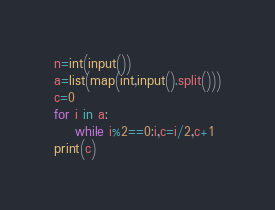Convert code to text. <code><loc_0><loc_0><loc_500><loc_500><_Python_>n=int(input())
a=list(map(int,input().split()))
c=0
for i in a:
    while i%2==0:i,c=i/2,c+1
print(c)</code> 